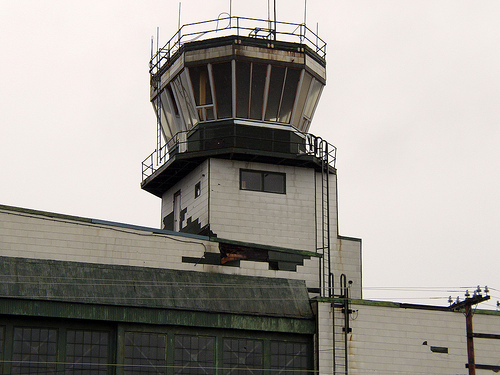<image>
Is the rod next to the sky? Yes. The rod is positioned adjacent to the sky, located nearby in the same general area. 